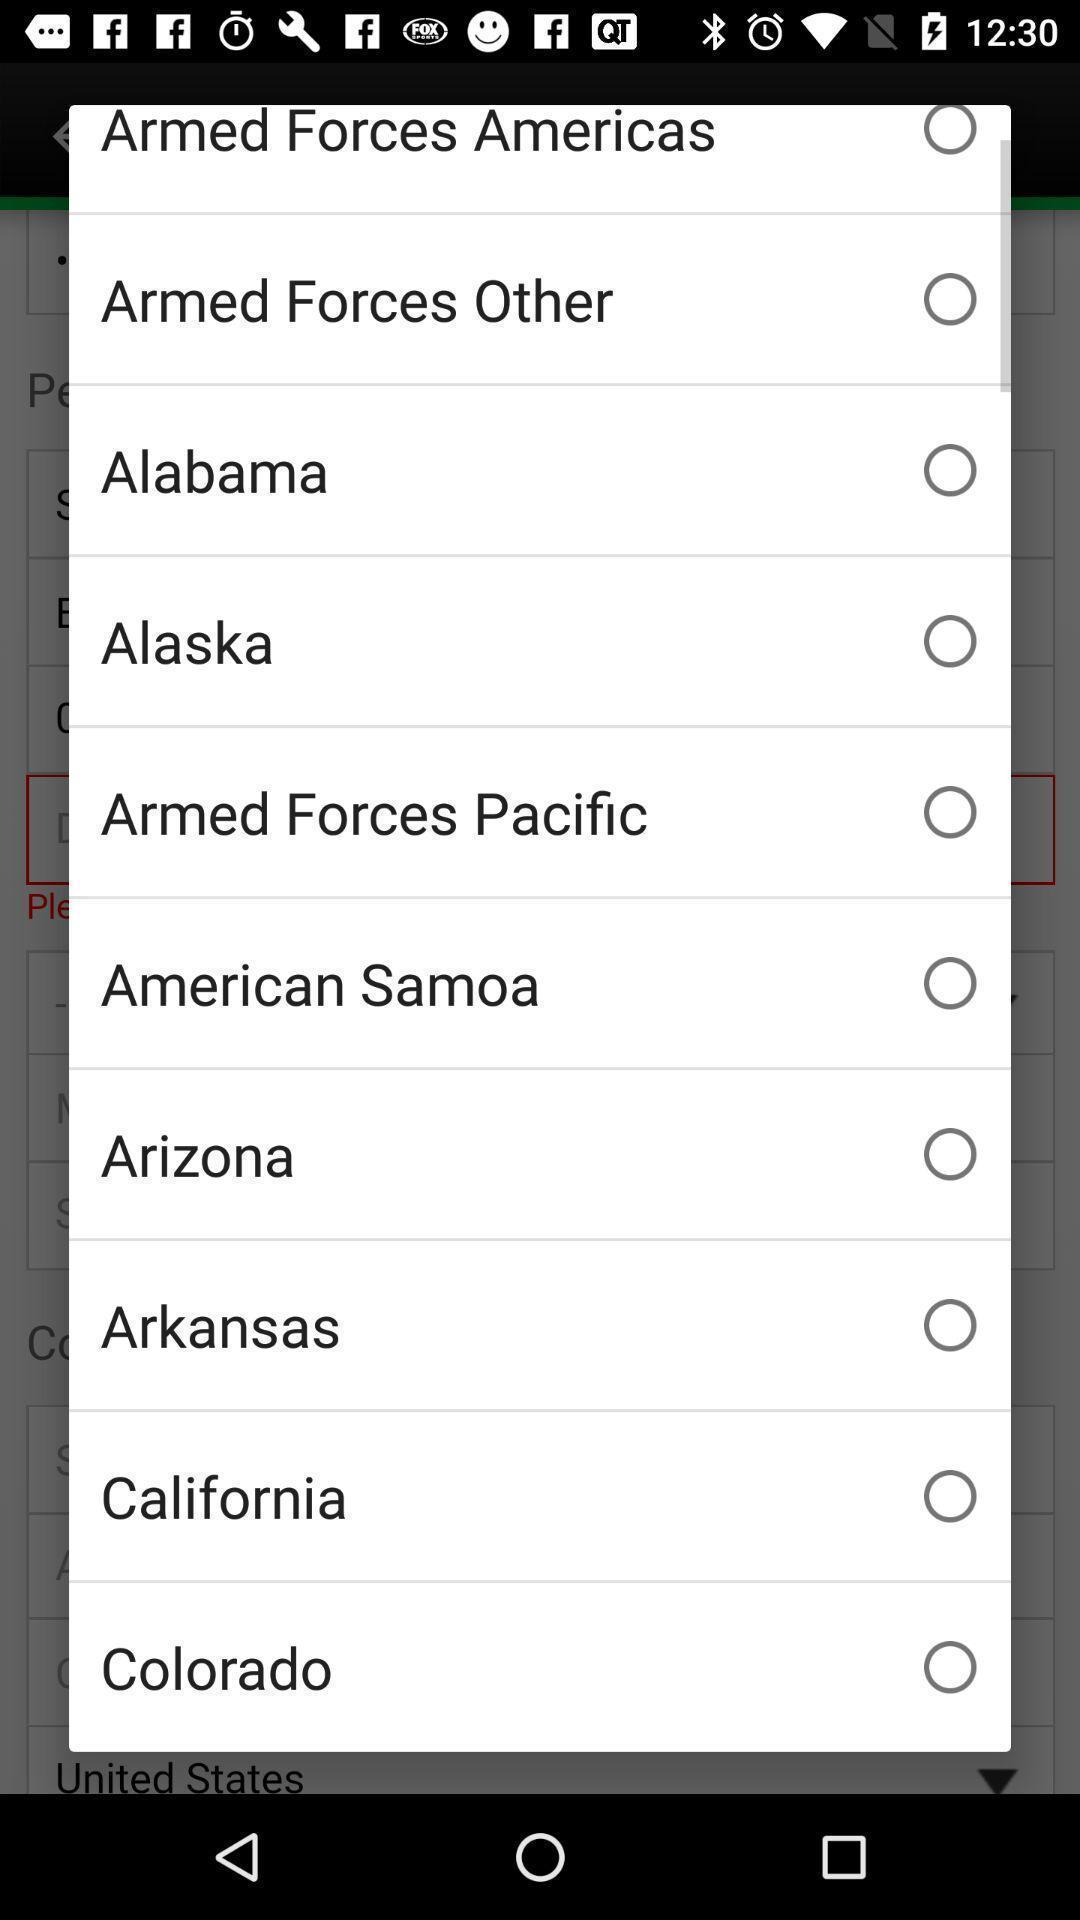Tell me about the visual elements in this screen capture. Pop-up showing to select a city. 